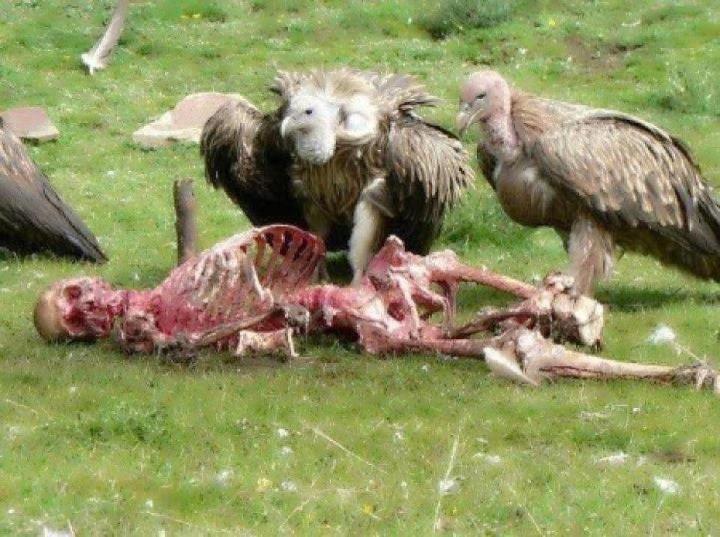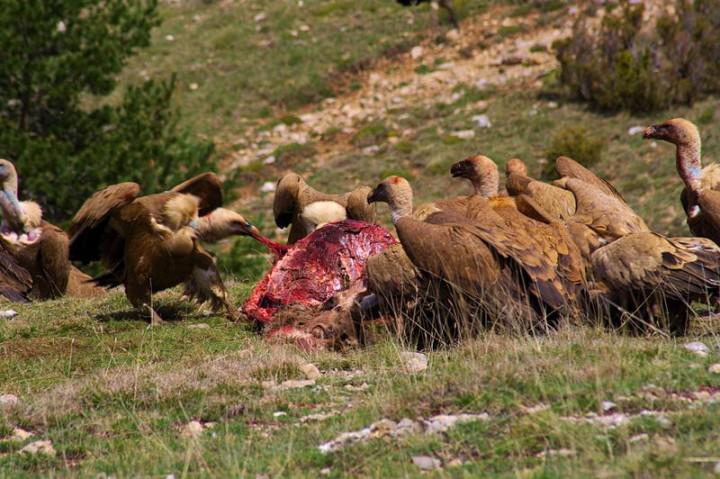The first image is the image on the left, the second image is the image on the right. For the images displayed, is the sentence "There is a human skeleton next to a group of vultures in one of the images." factually correct? Answer yes or no. Yes. 